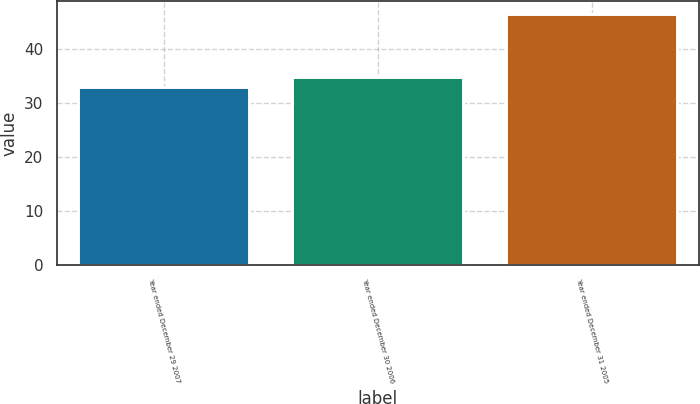Convert chart. <chart><loc_0><loc_0><loc_500><loc_500><bar_chart><fcel>Year ended December 29 2007<fcel>Year ended December 30 2006<fcel>Year ended December 31 2005<nl><fcel>32.9<fcel>34.9<fcel>46.5<nl></chart> 